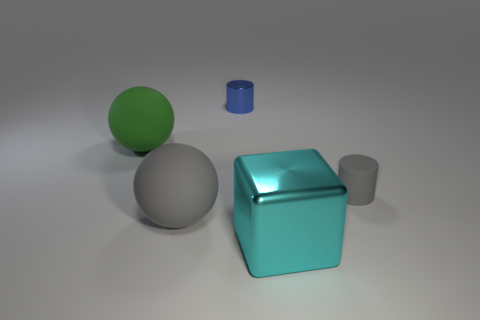Add 2 brown cylinders. How many objects exist? 7 Subtract all blocks. How many objects are left? 4 Add 4 small gray cylinders. How many small gray cylinders exist? 5 Subtract 0 yellow cylinders. How many objects are left? 5 Subtract all large matte balls. Subtract all small cylinders. How many objects are left? 1 Add 5 big cyan metallic things. How many big cyan metallic things are left? 6 